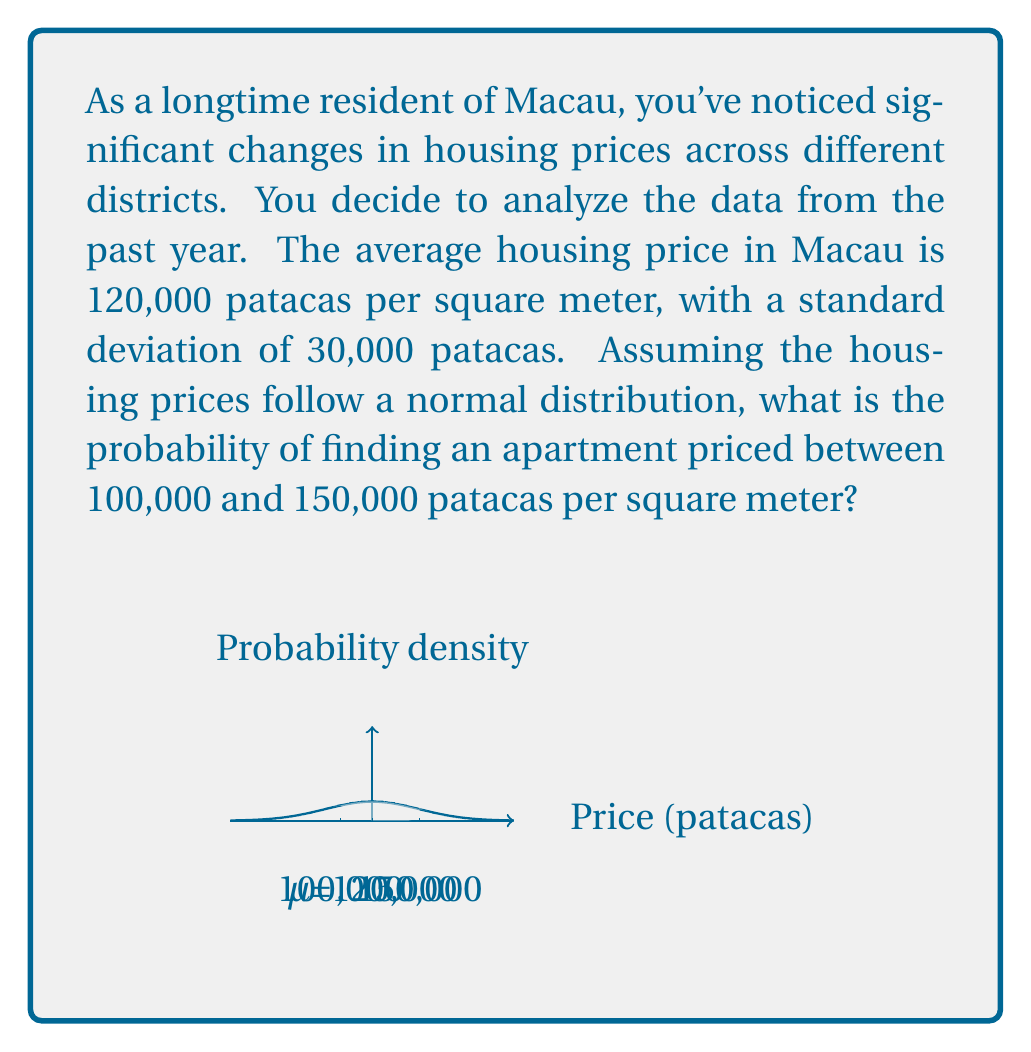Can you answer this question? To solve this problem, we'll use the standard normal distribution and the z-score formula.

Step 1: Calculate the z-scores for the given prices.
For 100,000 patacas: $z_1 = \frac{100000 - 120000}{30000} = -\frac{20000}{30000} = -\frac{2}{3}$
For 150,000 patacas: $z_2 = \frac{150000 - 120000}{30000} = \frac{30000}{30000} = 1$

Step 2: Use a standard normal distribution table or calculator to find the area under the curve between these z-scores.

$P(-\frac{2}{3} < Z < 1) = P(Z < 1) - P(Z < -\frac{2}{3})$

Using a standard normal distribution table or calculator:
$P(Z < 1) \approx 0.8413$
$P(Z < -\frac{2}{3}) \approx 0.2514$

Step 3: Calculate the difference to find the probability.
$P(-\frac{2}{3} < Z < 1) = 0.8413 - 0.2514 = 0.5899$

Therefore, the probability of finding an apartment priced between 100,000 and 150,000 patacas per square meter is approximately 0.5899 or 58.99%.
Answer: $0.5899$ or $58.99\%$ 